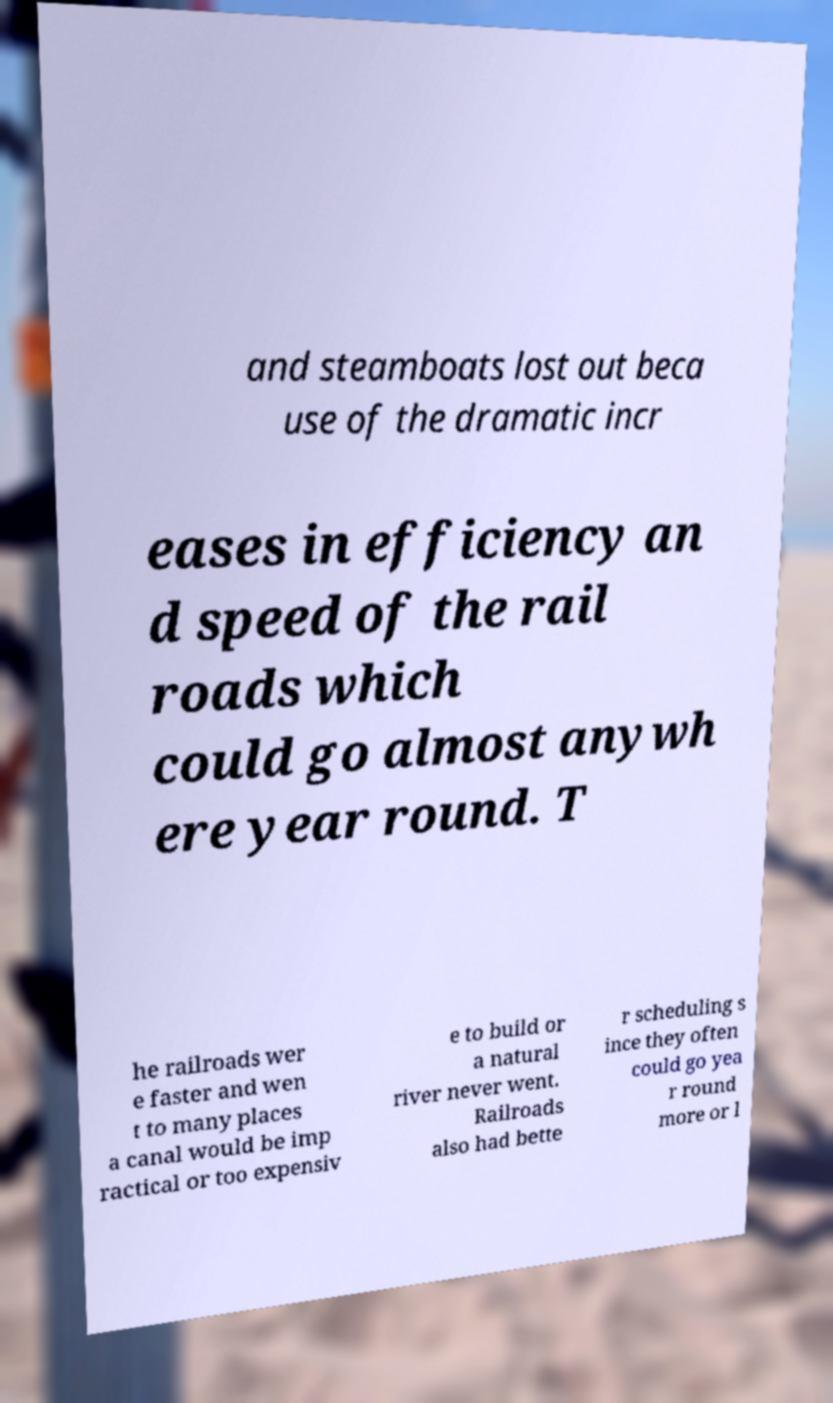Please read and relay the text visible in this image. What does it say? and steamboats lost out beca use of the dramatic incr eases in efficiency an d speed of the rail roads which could go almost anywh ere year round. T he railroads wer e faster and wen t to many places a canal would be imp ractical or too expensiv e to build or a natural river never went. Railroads also had bette r scheduling s ince they often could go yea r round more or l 